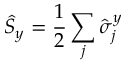Convert formula to latex. <formula><loc_0><loc_0><loc_500><loc_500>\hat { S } _ { y } = \frac { 1 } { 2 } \sum _ { j } \hat { \sigma } _ { j } ^ { y }</formula> 